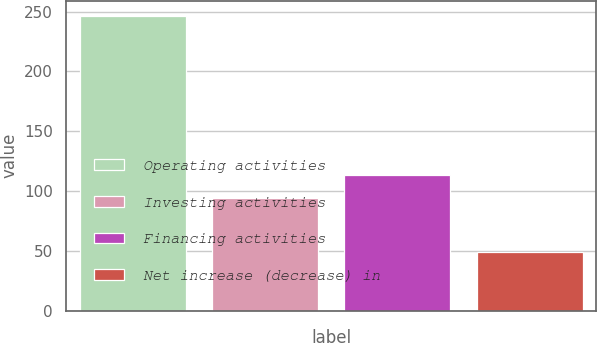Convert chart to OTSL. <chart><loc_0><loc_0><loc_500><loc_500><bar_chart><fcel>Operating activities<fcel>Investing activities<fcel>Financing activities<fcel>Net increase (decrease) in<nl><fcel>246.6<fcel>93.9<fcel>113.64<fcel>49.2<nl></chart> 